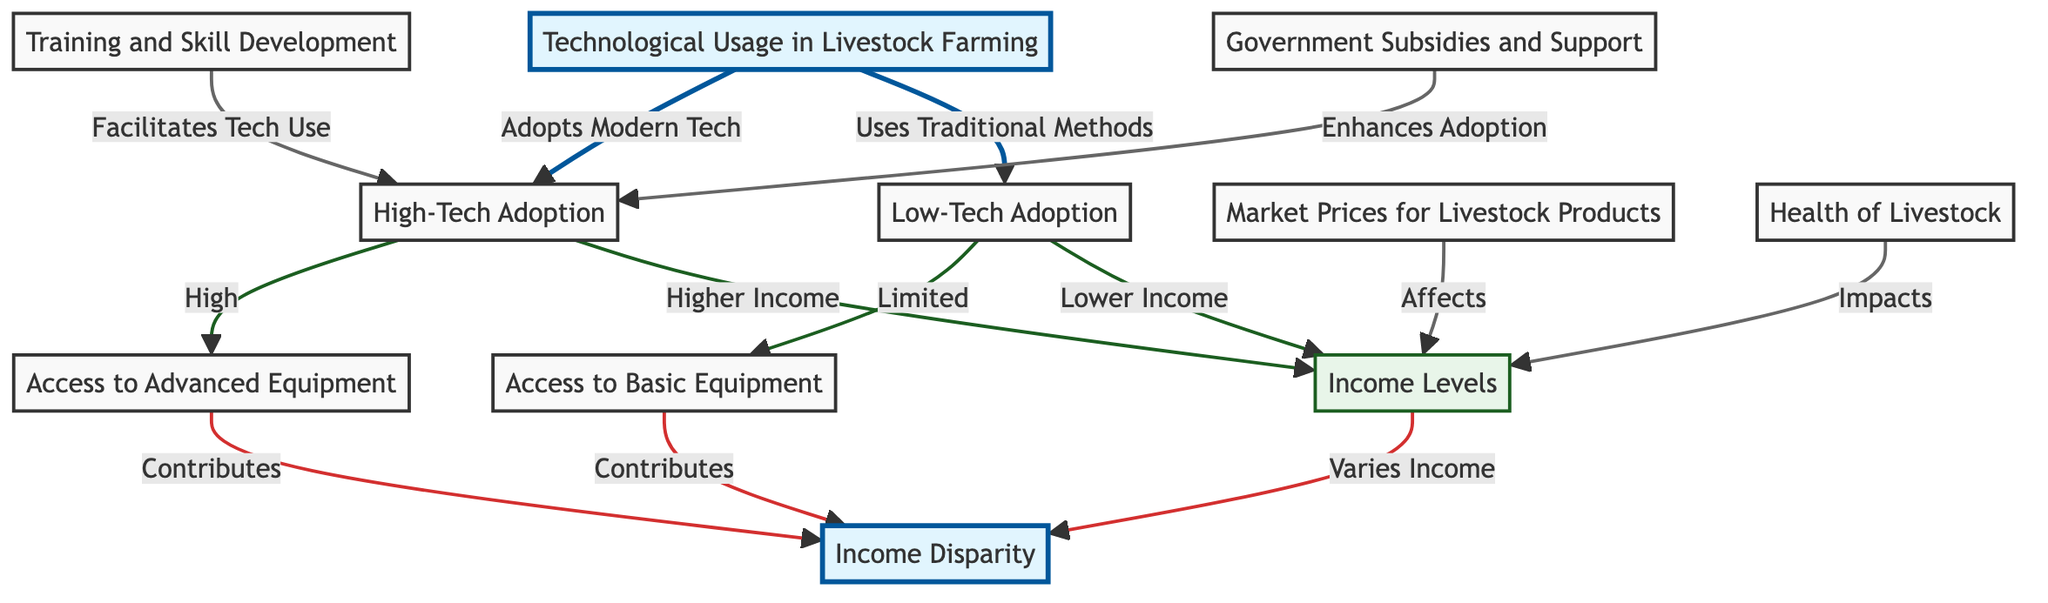What nodes represent Technological Usage in Livestock Farming? The diagram shows two nodes under Technological Usage: "High-Tech Adoption" and "Low-Tech Adoption." These nodes are directly connected to the central node representing Technological Usage in Livestock Farming.
Answer: High-Tech Adoption, Low-Tech Adoption How does High-Tech Adoption affect income levels? According to the diagram, High-Tech Adoption leads to a "Higher Income" level, indicating a direct positive correlation between the adoption of modern technology and income levels for livestock farmers.
Answer: Higher Income What contributes to income disparity? The diagram indicates that both "Access to Advanced Equipment" and "Access to Basic Equipment" contribute to income disparity. Therefore, these factors highlight how varying levels of equipment access lead to differences in income among livestock farmers.
Answer: Access to Advanced Equipment, Access to Basic Equipment What is the relationship between Training and Skill Development and High-Tech Adoption? The diagram shows that Training and Skill Development facilitates the use of High-Tech Adoption, suggesting that increasing skills and knowledge positively impacts the adoption of modern technologies in livestock farming.
Answer: Facilitates Which node is affected by Market Prices for Livestock Products? The diagram illustrates that Market Prices for Livestock Products affect the "Income Levels" node, indicating that fluctuations in market prices can directly influence the income of livestock farmers.
Answer: Income Levels What is the overall impact of livestock health on income levels? The diagram states that the Health of Livestock impacts Income Levels, highlighting the importance of livestock welfare on the economic success of farmers. This interdependence suggests that healthier livestock can lead to better income outcomes.
Answer: Impacts What is a key factor enhancing High-Tech Adoption? The diagram specifies that "Government Subsidies and Support" enhance High-Tech Adoption, meaning that financial or policy support from the government can encourage farmers to adopt more advanced technologies.
Answer: Enhances Adoption How many relationships are depicted in the diagram? There are 10 edges connecting the nodes, representing the relationships between different factors impacting income disparity among livestock farmers based on technological usage.
Answer: 10 What are the two types of technological adoption depicted in the diagram? The diagram represents two types of technological adoption: "High-Tech Adoption" and "Low-Tech Adoption." These two categories differentiate the levels of technology used by livestock farmers.
Answer: High-Tech Adoption, Low-Tech Adoption 